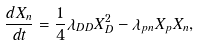Convert formula to latex. <formula><loc_0><loc_0><loc_500><loc_500>\frac { d X _ { n } } { d t } = \frac { 1 } { 4 } \lambda _ { D D } X _ { D } ^ { 2 } - \lambda _ { p n } X _ { p } X _ { n } ,</formula> 